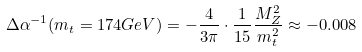Convert formula to latex. <formula><loc_0><loc_0><loc_500><loc_500>\Delta \alpha ^ { - 1 } ( m _ { t } = 1 7 4 G e V ) = - \frac { 4 } { 3 \pi } \cdot \frac { 1 } { 1 5 } \frac { M ^ { 2 } _ { Z } } { m ^ { 2 } _ { t } } \approx - 0 . 0 0 8</formula> 